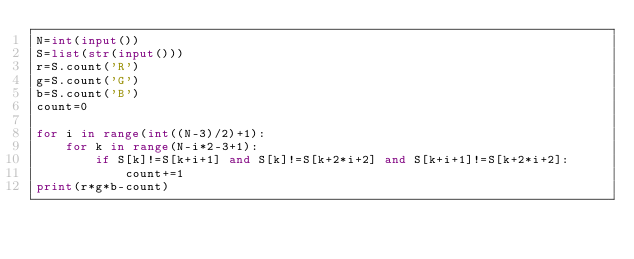Convert code to text. <code><loc_0><loc_0><loc_500><loc_500><_Python_>N=int(input())
S=list(str(input()))
r=S.count('R')
g=S.count('G')
b=S.count('B')
count=0

for i in range(int((N-3)/2)+1):
    for k in range(N-i*2-3+1):
        if S[k]!=S[k+i+1] and S[k]!=S[k+2*i+2] and S[k+i+1]!=S[k+2*i+2]:
            count+=1
print(r*g*b-count)</code> 